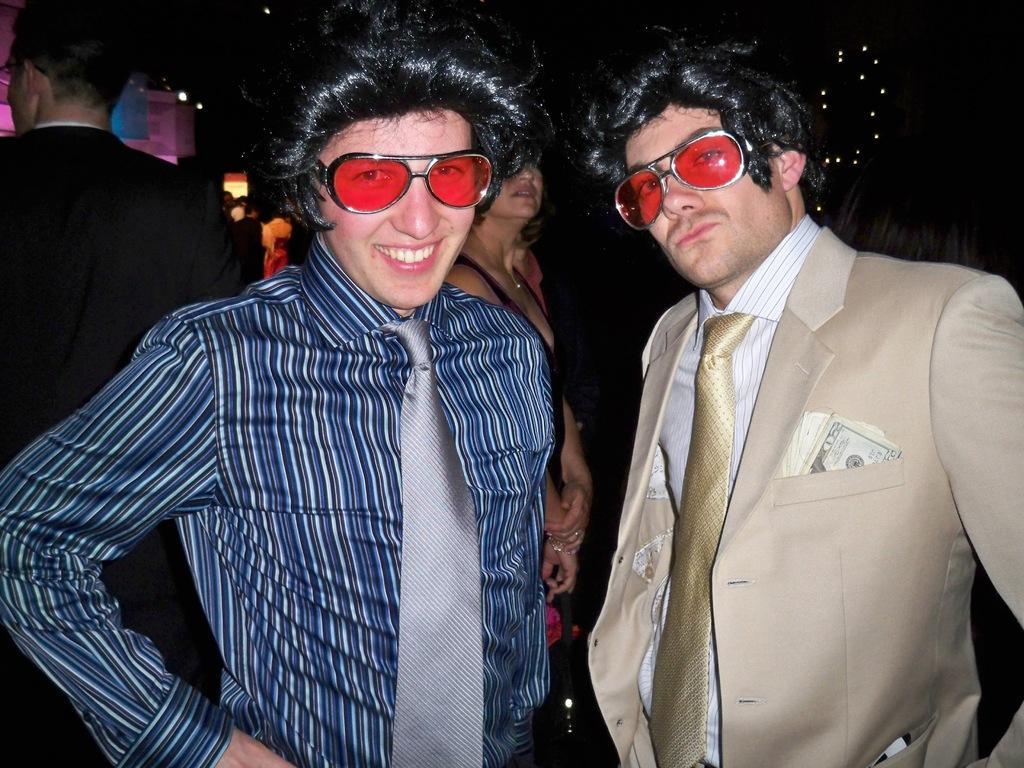Can you describe this image briefly? In this picture there are two persons standing and wearing goggles and wigs. 